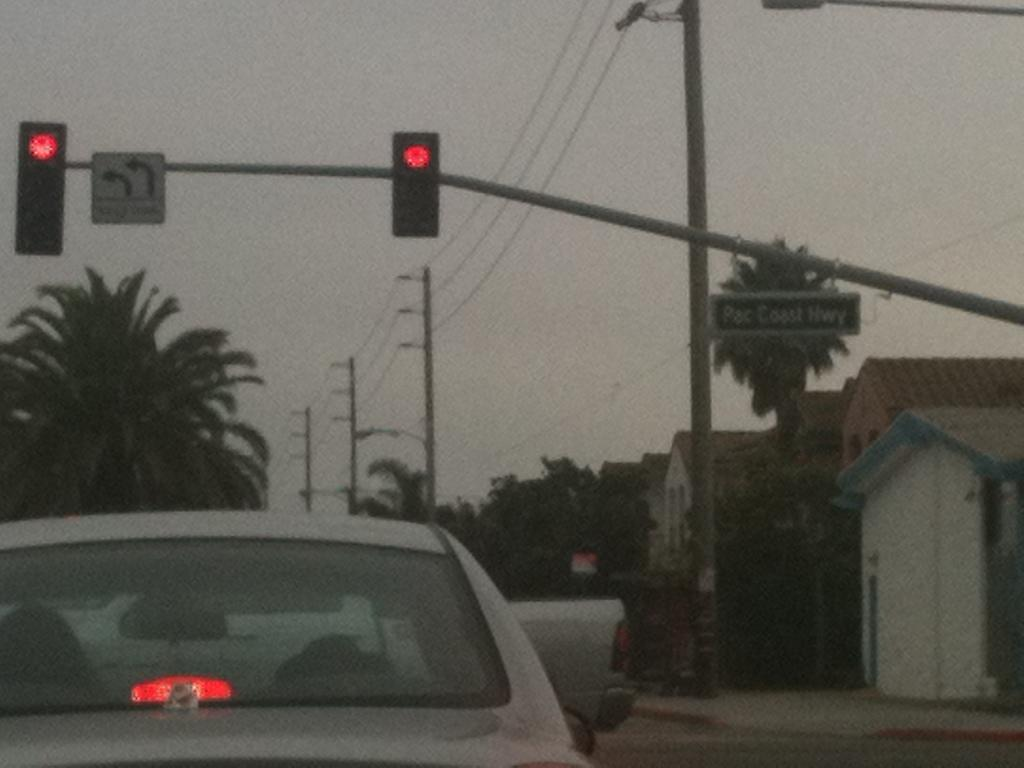Provide a one-sentence caption for the provided image. A car is sitting at a red light at the intersection of Pac Coast Hwy. 